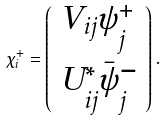<formula> <loc_0><loc_0><loc_500><loc_500>\chi _ { i } ^ { + } = \left ( \begin{array} { l } { { V _ { i j } \psi _ { j } ^ { + } } } \\ { { U _ { i j } ^ { * } \bar { \psi } _ { j } ^ { - } } } \end{array} \right ) .</formula> 